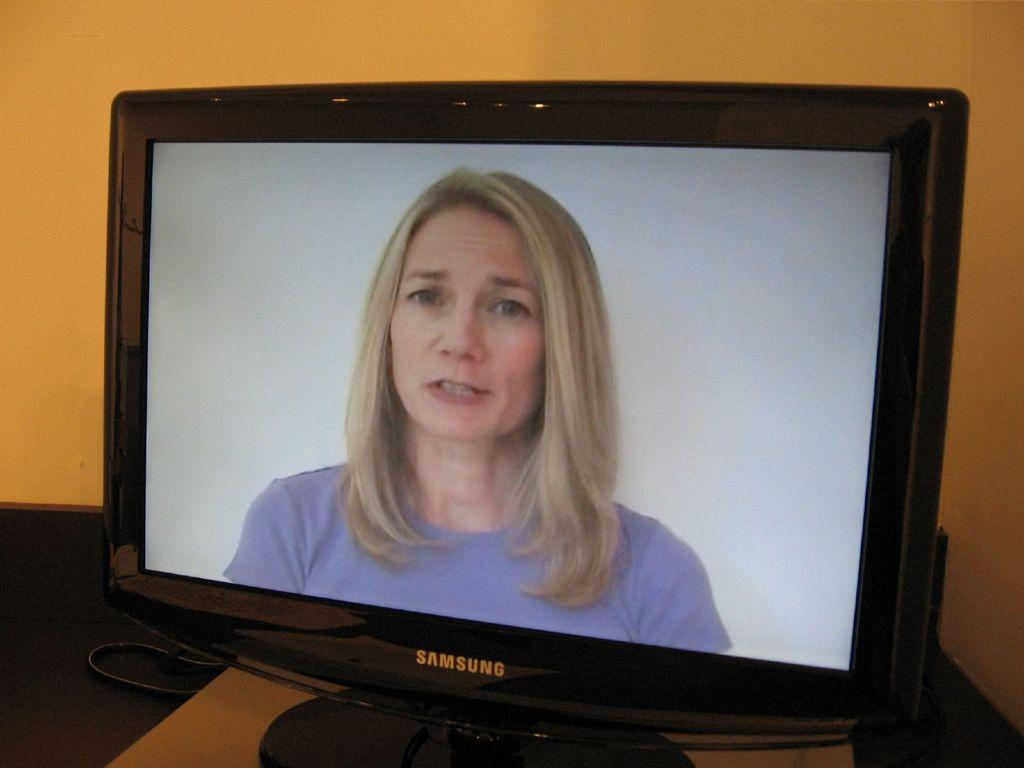<image>
Provide a brief description of the given image. Screen from Samsung showing a woman on the screen. 